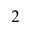<formula> <loc_0><loc_0><loc_500><loc_500>_ { 2 }</formula> 